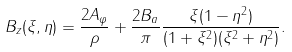Convert formula to latex. <formula><loc_0><loc_0><loc_500><loc_500>B _ { z } ( \xi , \eta ) = \frac { 2 A _ { \varphi } } { \rho } + \frac { 2 B _ { a } } { \pi } \frac { \xi ( 1 - \eta ^ { 2 } ) } { ( 1 + \xi ^ { 2 } ) ( \xi ^ { 2 } + \eta ^ { 2 } ) } .</formula> 